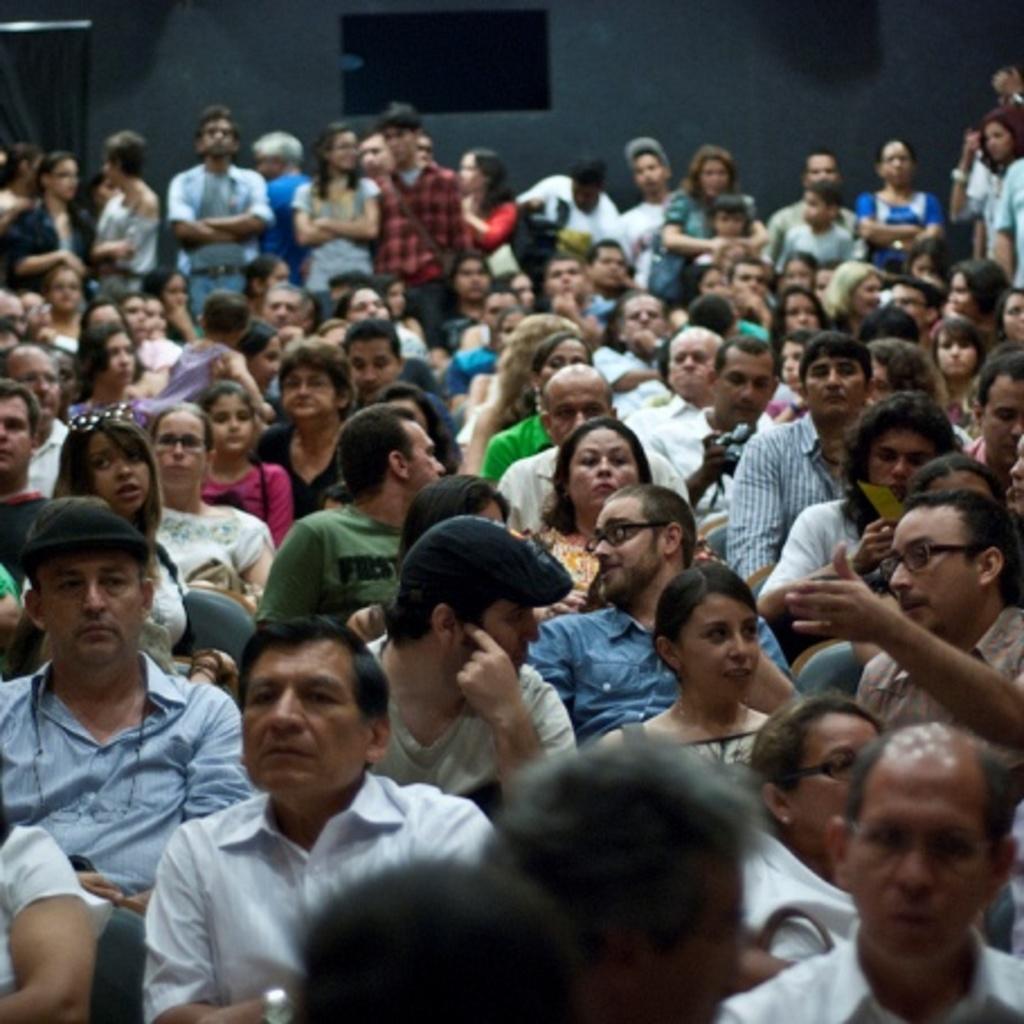Please provide a concise description of this image. In the center of the image there are many people sitting on chairs. In the background of the image there are few people standing and there is a wall. 